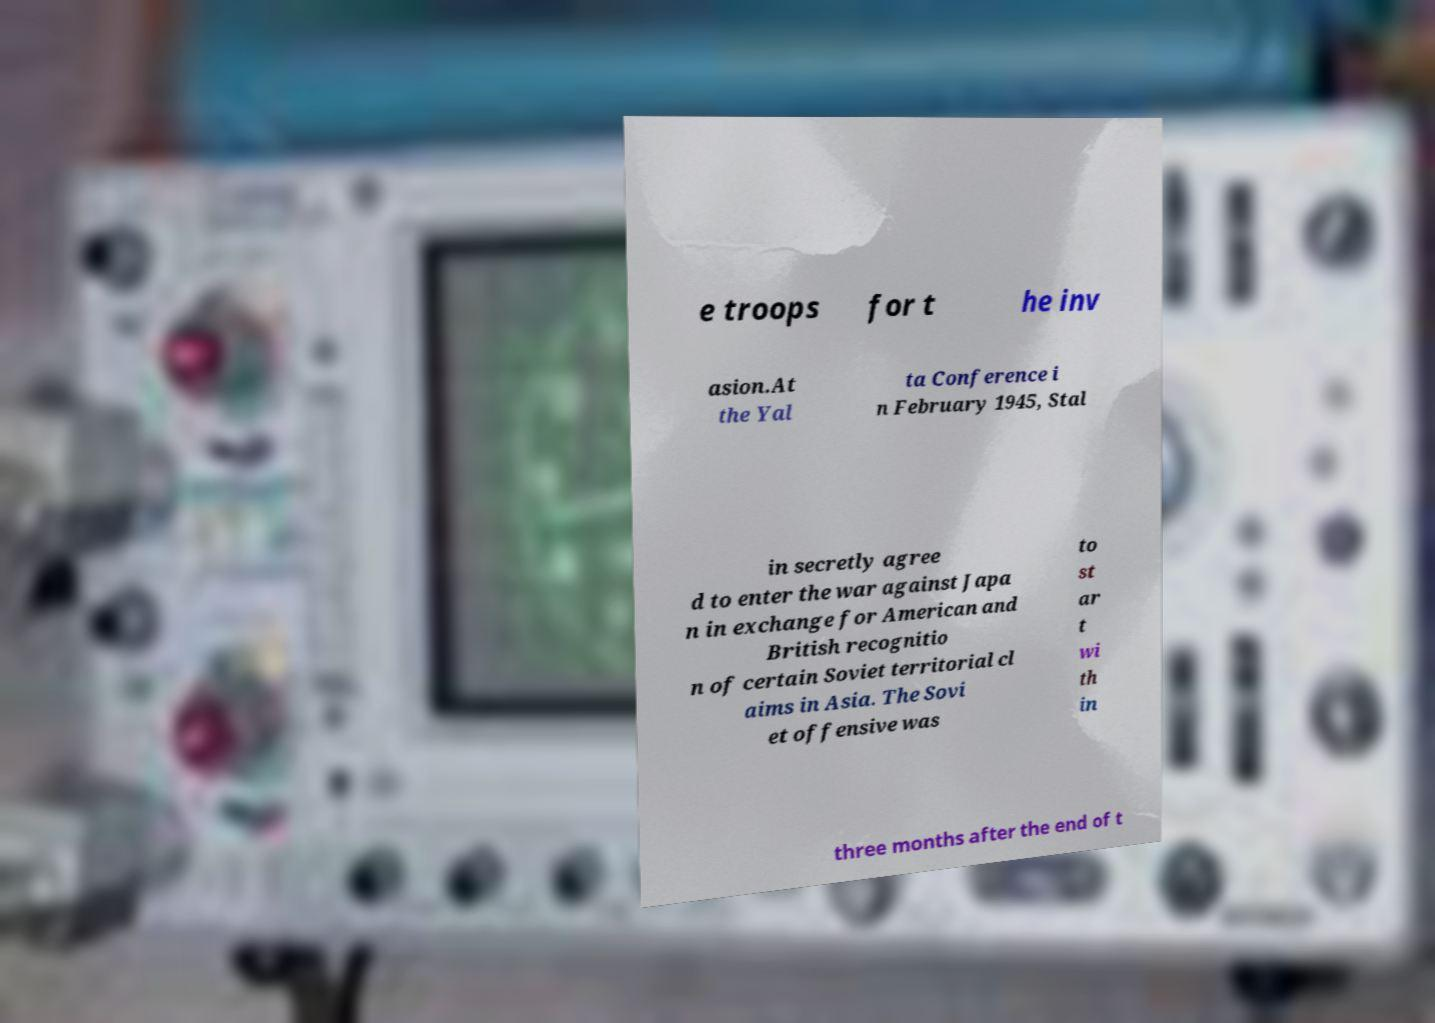Can you accurately transcribe the text from the provided image for me? e troops for t he inv asion.At the Yal ta Conference i n February 1945, Stal in secretly agree d to enter the war against Japa n in exchange for American and British recognitio n of certain Soviet territorial cl aims in Asia. The Sovi et offensive was to st ar t wi th in three months after the end of t 